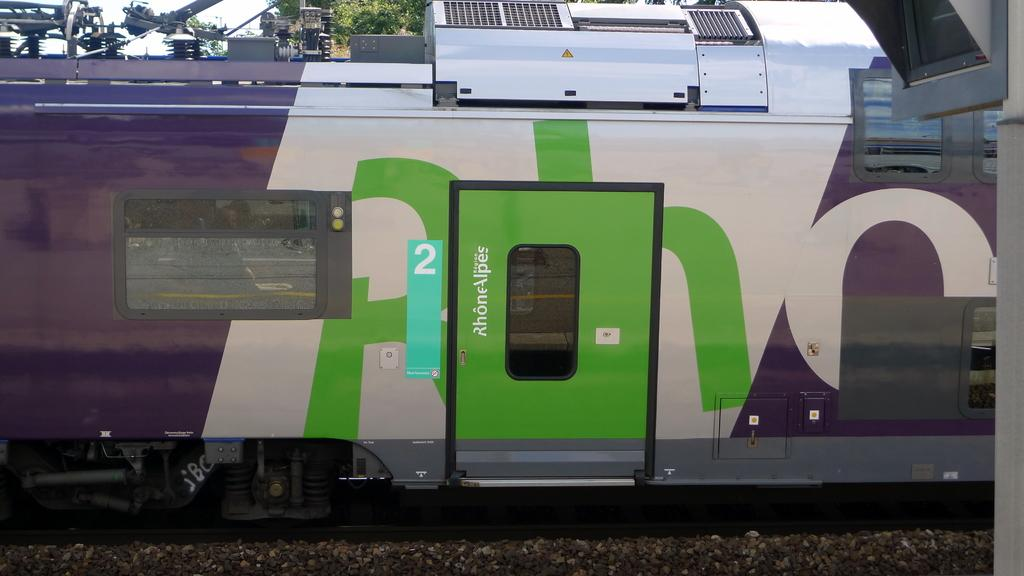What is the main subject of the image? The main subject of the image is a train. Where is the train located in the image? The train is on a railway track. What else can be seen in the image besides the train? There is a door visible in the image, as well as a signal pole on the right side. What is visible in the background of the image? In the background of the image, there are trees and the sky. What type of idea is being expressed by the hose in the image? There is no hose present in the image, so it cannot express any ideas. 